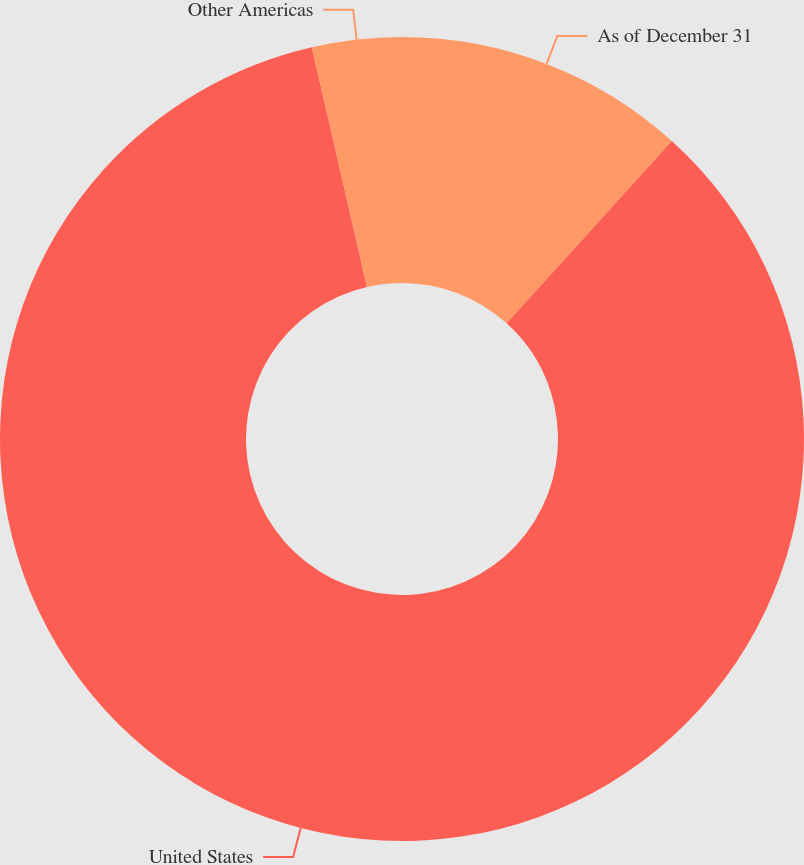<chart> <loc_0><loc_0><loc_500><loc_500><pie_chart><fcel>As of December 31<fcel>United States<fcel>Other Americas<nl><fcel>11.71%<fcel>84.7%<fcel>3.6%<nl></chart> 